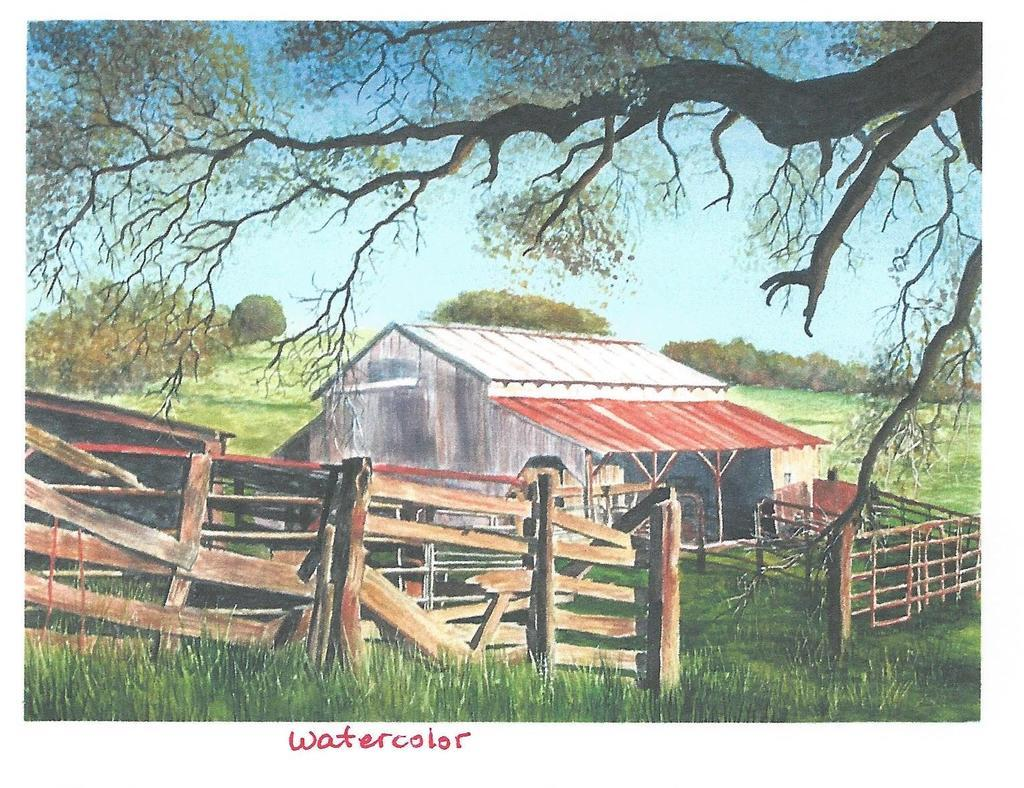Provide a one-sentence caption for the provided image. Waltercolor painting of and old barn and fencing in the country. 